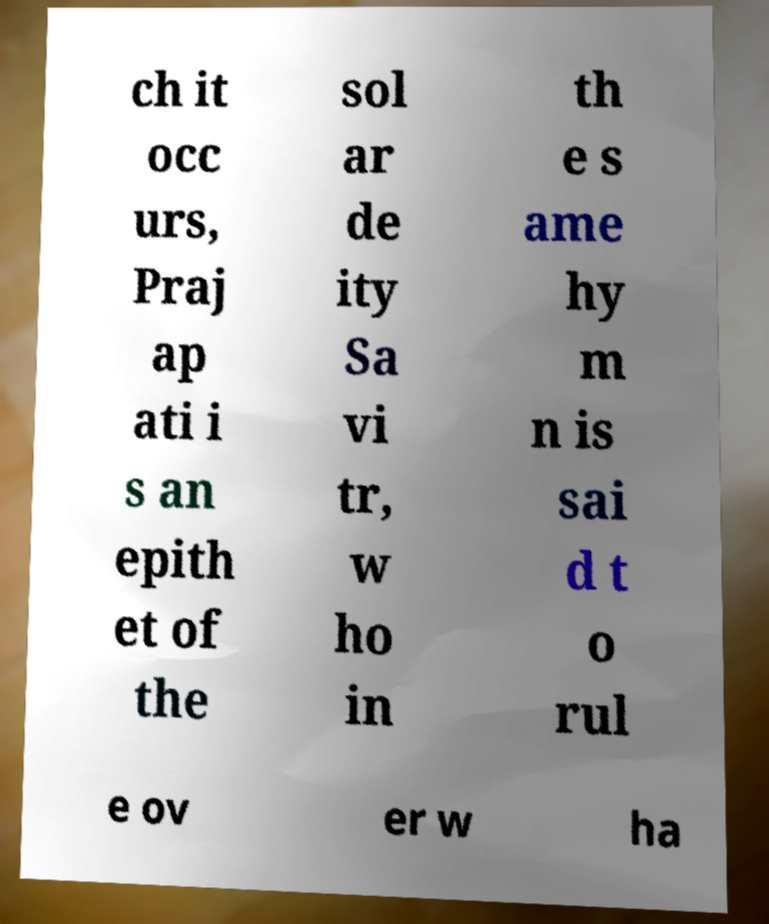For documentation purposes, I need the text within this image transcribed. Could you provide that? ch it occ urs, Praj ap ati i s an epith et of the sol ar de ity Sa vi tr, w ho in th e s ame hy m n is sai d t o rul e ov er w ha 